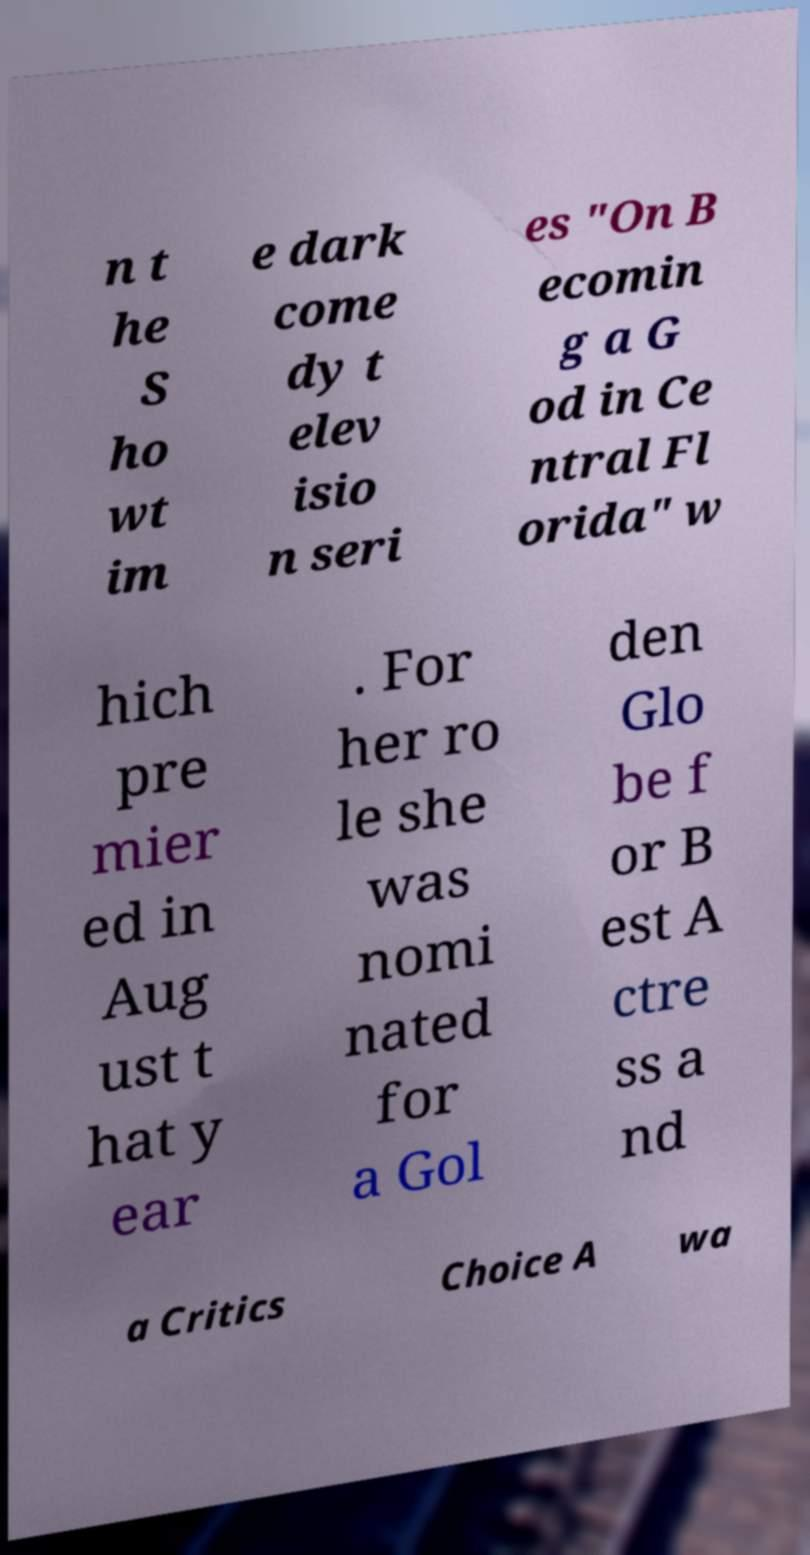Please identify and transcribe the text found in this image. n t he S ho wt im e dark come dy t elev isio n seri es "On B ecomin g a G od in Ce ntral Fl orida" w hich pre mier ed in Aug ust t hat y ear . For her ro le she was nomi nated for a Gol den Glo be f or B est A ctre ss a nd a Critics Choice A wa 